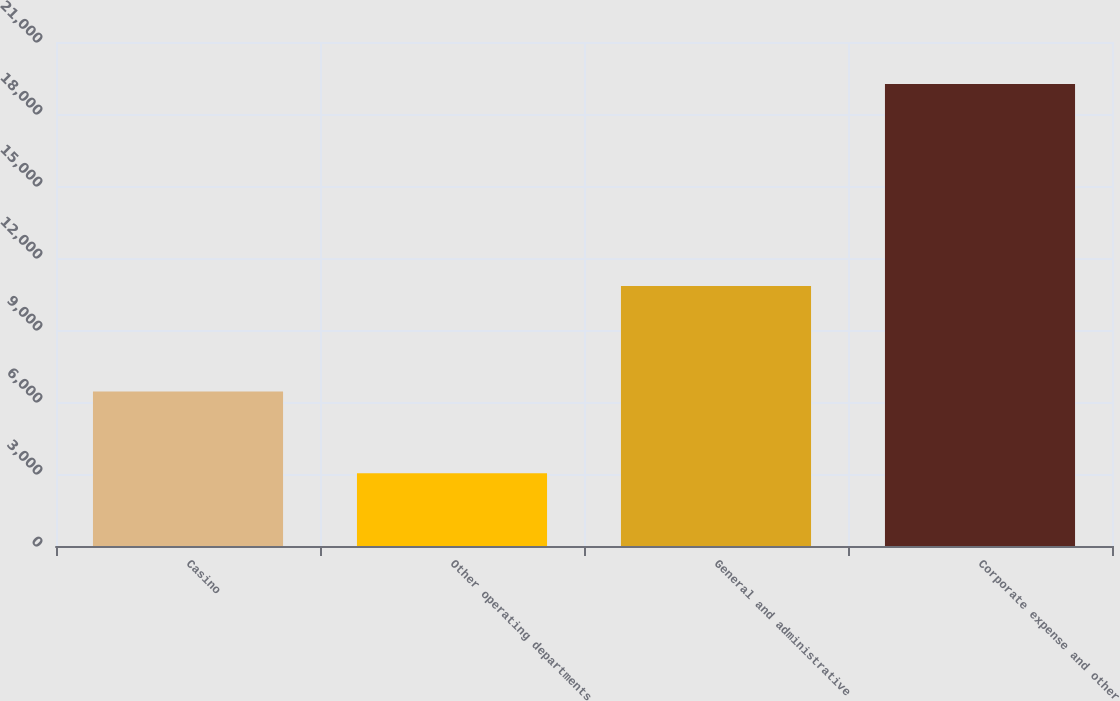Convert chart. <chart><loc_0><loc_0><loc_500><loc_500><bar_chart><fcel>Casino<fcel>Other operating departments<fcel>General and administrative<fcel>Corporate expense and other<nl><fcel>6437<fcel>3035<fcel>10837<fcel>19251<nl></chart> 